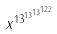<formula> <loc_0><loc_0><loc_500><loc_500>x ^ { 1 3 ^ { 1 3 ^ { 1 3 ^ { 1 2 2 } } } }</formula> 